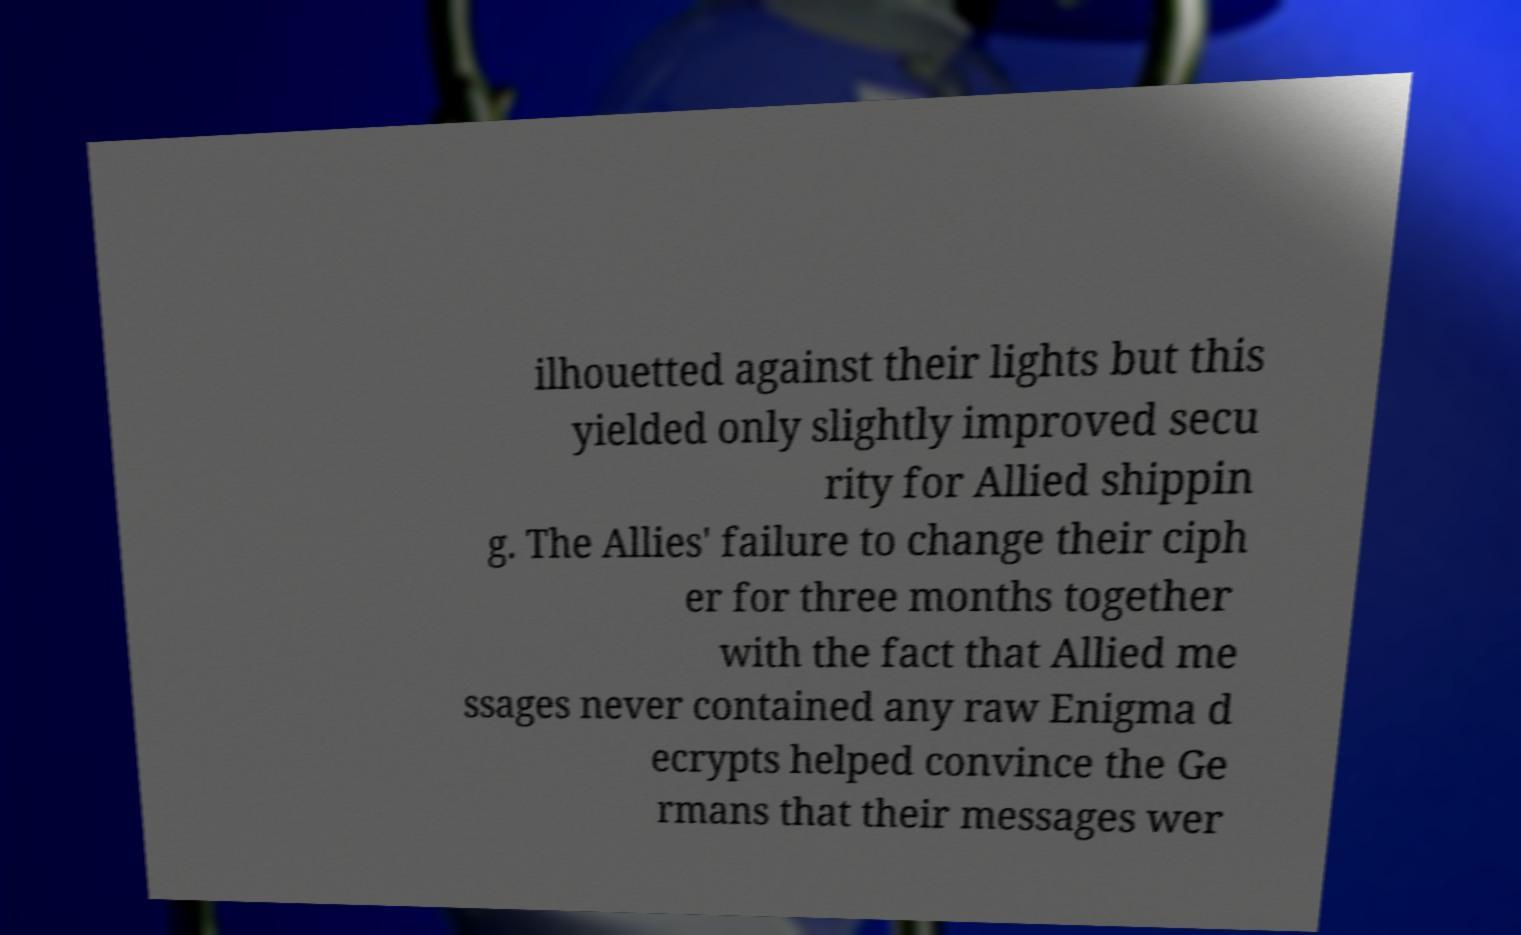Please read and relay the text visible in this image. What does it say? ilhouetted against their lights but this yielded only slightly improved secu rity for Allied shippin g. The Allies' failure to change their ciph er for three months together with the fact that Allied me ssages never contained any raw Enigma d ecrypts helped convince the Ge rmans that their messages wer 